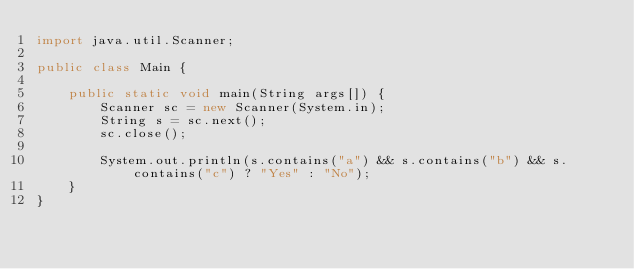Convert code to text. <code><loc_0><loc_0><loc_500><loc_500><_Java_>import java.util.Scanner;

public class Main {

	public static void main(String args[]) {
		Scanner sc = new Scanner(System.in);
		String s = sc.next();
		sc.close();

		System.out.println(s.contains("a") && s.contains("b") && s.contains("c") ? "Yes" : "No");
	}
}</code> 